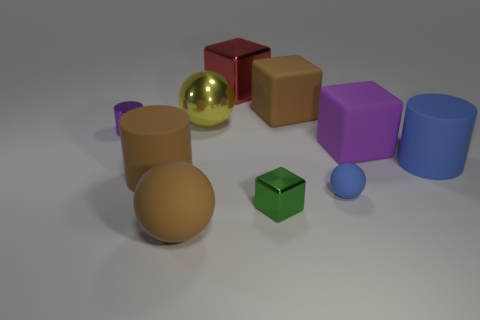There is a thing that is both on the left side of the large red shiny cube and in front of the small blue ball; what is its material?
Your response must be concise. Rubber. What shape is the blue rubber thing in front of the large blue object?
Give a very brief answer. Sphere. What number of tiny purple cylinders have the same material as the red object?
Your answer should be compact. 1. There is a purple rubber object; is its shape the same as the small metallic object behind the purple matte cube?
Offer a very short reply. No. Are there any small metal cylinders that are to the right of the large blue matte cylinder right of the big brown object that is behind the blue matte cylinder?
Your response must be concise. No. How big is the brown matte thing that is to the right of the large yellow object?
Offer a terse response. Large. There is a blue ball that is the same size as the green metal object; what is it made of?
Your answer should be very brief. Rubber. Does the big yellow metal object have the same shape as the small blue thing?
Keep it short and to the point. Yes. How many objects are either tiny yellow shiny objects or balls behind the blue rubber cylinder?
Your answer should be compact. 1. There is a big object that is the same color as the small metal cylinder; what is it made of?
Offer a terse response. Rubber. 